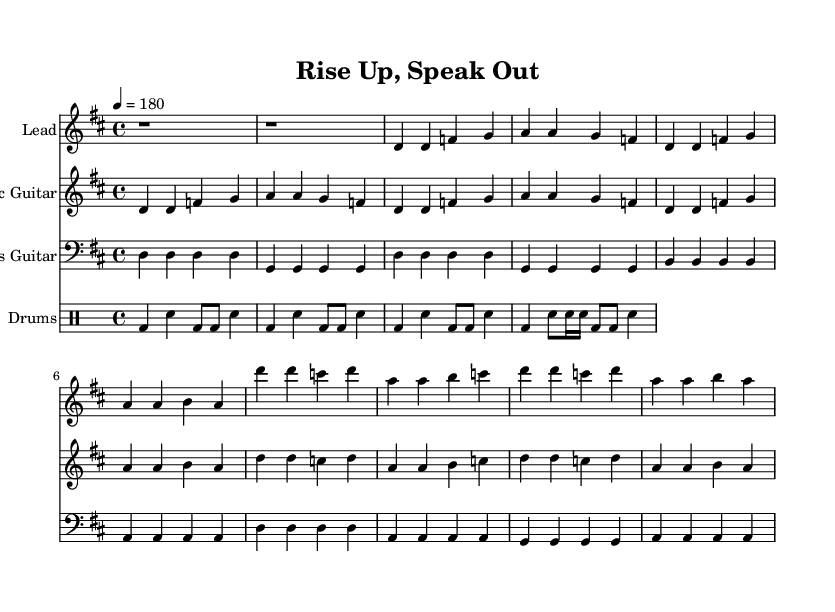What is the key signature of this music? The key signature is D major, which has two sharps (F# and C#) indicated at the beginning of the staff.
Answer: D major What is the time signature of this music? The time signature is 4/4, which is shown next to the key signature at the beginning of the sheet music.
Answer: 4/4 What is the tempo marking of the piece? The tempo marking indicates a speed of quarter note equals 180, which is specified under the tempo section at the beginning of the score.
Answer: 180 How many measures are in the chorus section? The chorus contains four measures, which can be counted from the corresponding section in the sheet music.
Answer: 4 What is the main theme of the lyrics? The lyrics emphasize empowerment and urgency, concerning social change and civil rights, as reflected in the phrases “Rise up, speak out” and “Our time is now.”
Answer: Empowerment Which instrument is primarily responsible for the melody? The melody is primarily carried by the lead vocal, which is denoted by the melody staff and is the first staff in the score.
Answer: Lead What kind of musical elements characterize this punk track? The track incorporates fast-paced rhythms, strong beats typical of punk, and a repetitive structure emphasizing the message of social activism, seen in the consistent drum and guitar patterns.
Answer: Fast-paced rhythms 